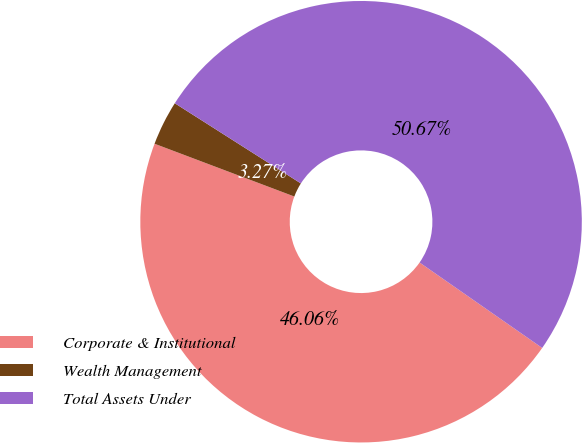Convert chart. <chart><loc_0><loc_0><loc_500><loc_500><pie_chart><fcel>Corporate & Institutional<fcel>Wealth Management<fcel>Total Assets Under<nl><fcel>46.06%<fcel>3.27%<fcel>50.67%<nl></chart> 